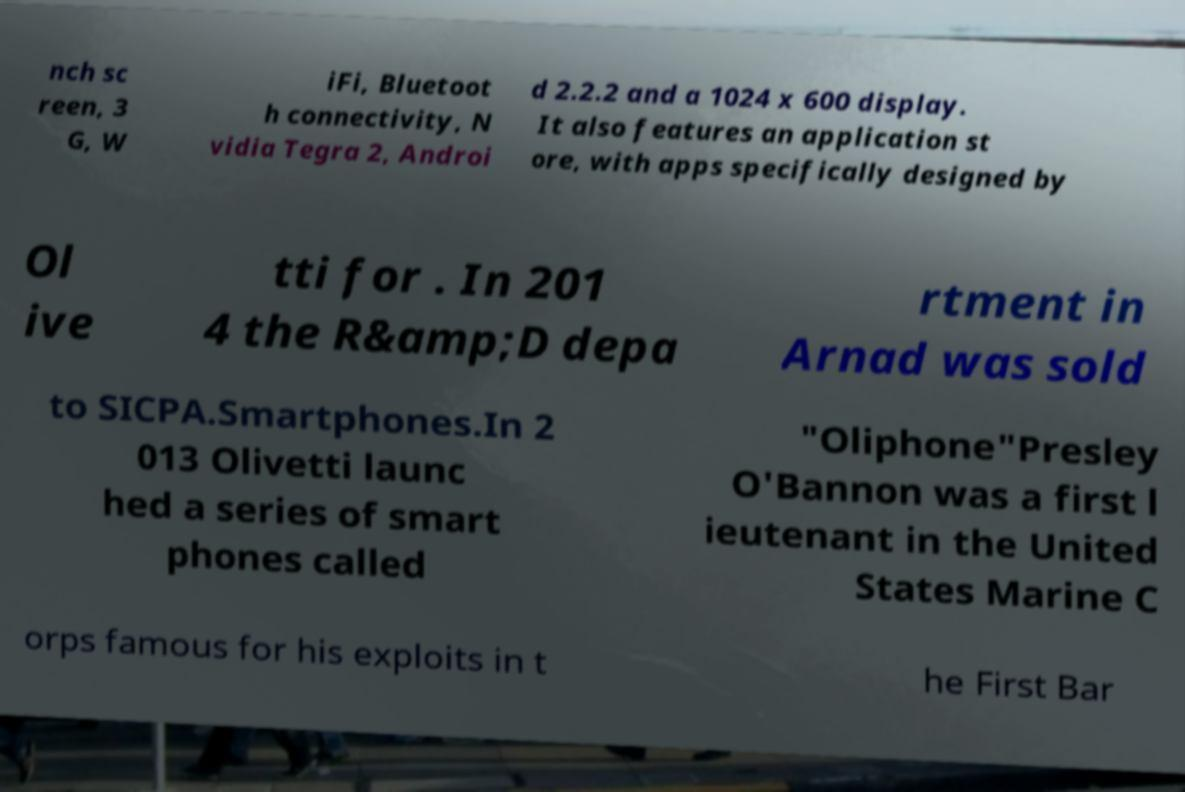Please identify and transcribe the text found in this image. nch sc reen, 3 G, W iFi, Bluetoot h connectivity, N vidia Tegra 2, Androi d 2.2.2 and a 1024 x 600 display. It also features an application st ore, with apps specifically designed by Ol ive tti for . In 201 4 the R&amp;D depa rtment in Arnad was sold to SICPA.Smartphones.In 2 013 Olivetti launc hed a series of smart phones called "Oliphone"Presley O'Bannon was a first l ieutenant in the United States Marine C orps famous for his exploits in t he First Bar 